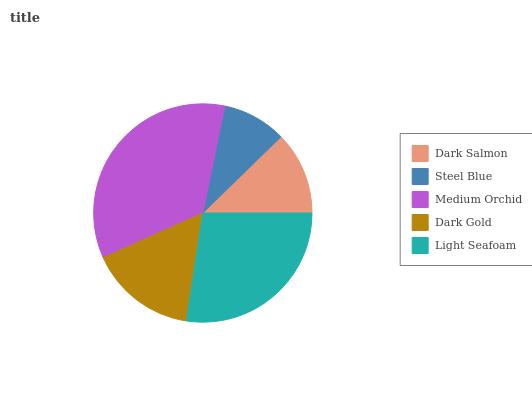Is Steel Blue the minimum?
Answer yes or no. Yes. Is Medium Orchid the maximum?
Answer yes or no. Yes. Is Medium Orchid the minimum?
Answer yes or no. No. Is Steel Blue the maximum?
Answer yes or no. No. Is Medium Orchid greater than Steel Blue?
Answer yes or no. Yes. Is Steel Blue less than Medium Orchid?
Answer yes or no. Yes. Is Steel Blue greater than Medium Orchid?
Answer yes or no. No. Is Medium Orchid less than Steel Blue?
Answer yes or no. No. Is Dark Gold the high median?
Answer yes or no. Yes. Is Dark Gold the low median?
Answer yes or no. Yes. Is Light Seafoam the high median?
Answer yes or no. No. Is Dark Salmon the low median?
Answer yes or no. No. 